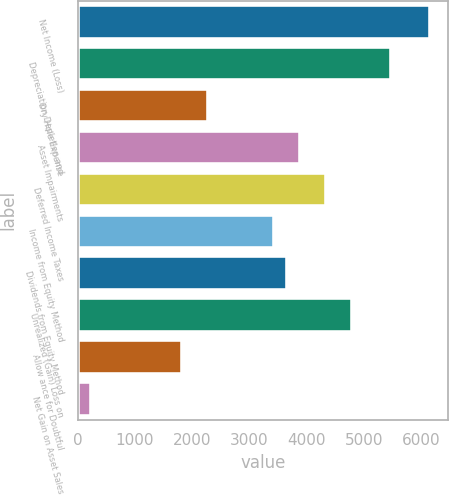Convert chart to OTSL. <chart><loc_0><loc_0><loc_500><loc_500><bar_chart><fcel>Net Income (Loss)<fcel>Depreciation Depletion and<fcel>Dry Hole Expense<fcel>Asset Impairments<fcel>Deferred Income Taxes<fcel>Income from Equity Method<fcel>Dividends from Equity Method<fcel>Unrealized (Gain) Loss on<fcel>Allow ance for Doubtful<fcel>Net Gain on Asset Sales<nl><fcel>6164.4<fcel>5479.8<fcel>2285<fcel>3882.4<fcel>4338.8<fcel>3426<fcel>3654.2<fcel>4795.2<fcel>1828.6<fcel>231.2<nl></chart> 